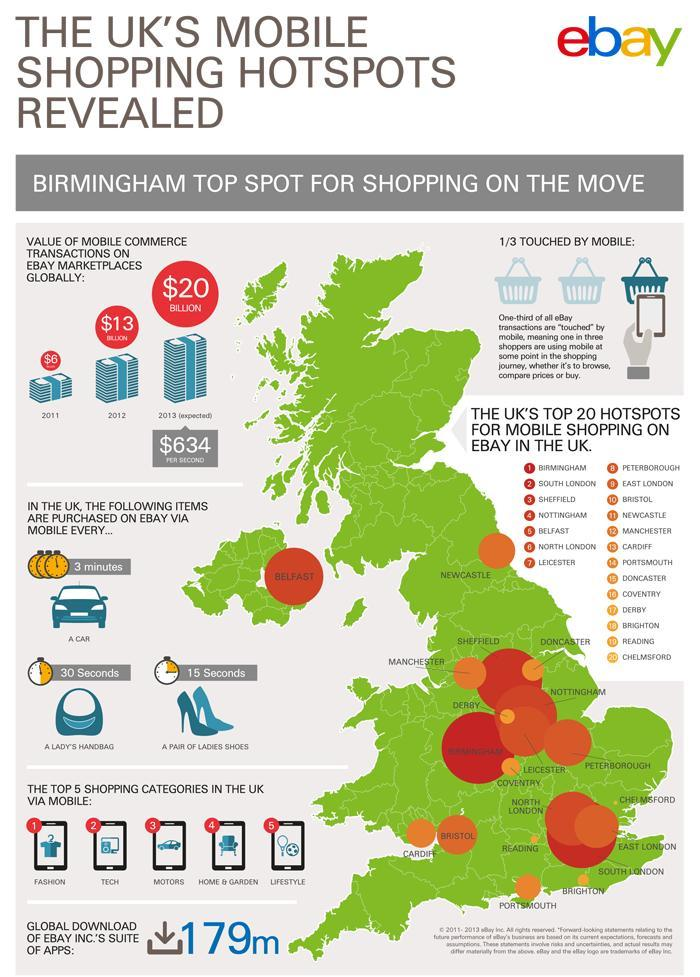Which product in UK is being sold through E bay in every 15 seconds?
Answer the question with a short phrase. A pair of Ladies Shoes How much is the worth of E bay Mobile transactions for a second? $634 Which is the second most product shopped through mobile in UK? Tech Which product in UK is being sold through E bay in every 30 seconds? A Lady's Handbag Which is the fifth most product shopped through mobile in UK? Lifestyle What percentage of E bay users are not using mobile? 2/3 